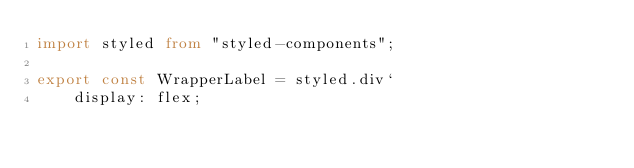<code> <loc_0><loc_0><loc_500><loc_500><_TypeScript_>import styled from "styled-components";

export const WrapperLabel = styled.div`
    display: flex;</code> 